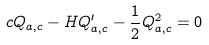Convert formula to latex. <formula><loc_0><loc_0><loc_500><loc_500>c Q _ { a , c } - H Q _ { a , c } ^ { \prime } - \frac { 1 } { 2 } Q ^ { 2 } _ { a , c } = 0</formula> 